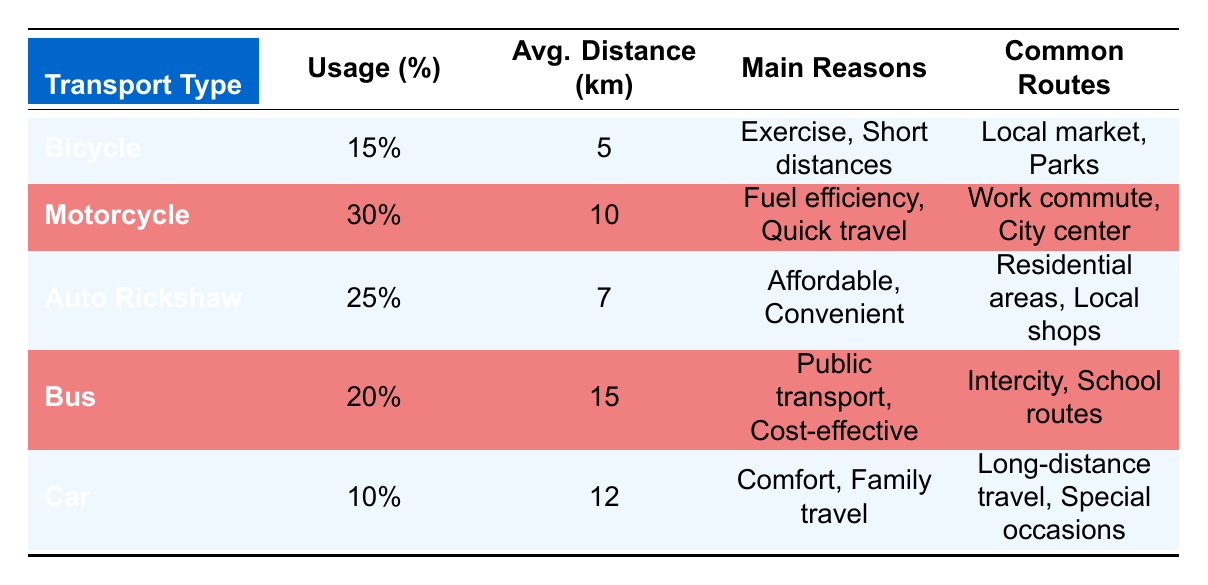What is the most commonly used mode of transportation in Jalalpore? According to the table, the mode of transportation with the highest usage percentage is the Motorcycle at 30%.
Answer: Motorcycle What percentage of residents use Bicycles for transportation? The table shows that 15% of residents use Bicycles.
Answer: 15% What is the average distance traveled by Bus users? The average distance traveled by Bus users is indicated in the table as 15 km.
Answer: 15 km Which transportation type is used for long-distance travel? The Car is highlighted in the table as the type used for long-distance travel, as it is mentioned in the common routes.
Answer: Car Are Auto Rickshaws more commonly used than Cars? Yes, Auto Rickshaws have a usage percentage of 25%, while Cars have only 10%, confirming that Auto Rickshaws are more commonly used.
Answer: Yes What is the average distance traveled by users of all transportation types combined? To find the average distance traveled, we should calculate the weighted average based on usage. Multiplying each average distance by its usage percentage and summing them up gives us (5*0.15 + 10*0.30 + 7*0.25 + 15*0.20 + 12*0.10) = 8.55 km. The average distance traveled by users of all transportation types is approximately 8.55 km.
Answer: 8.55 km Which type of transportation has the least common usage amongst the residents? The Car has the least common usage at 10%, as indicated in the table.
Answer: Car Is the primary reason for using a Motorcycle more focused on fuel efficiency than for using a Bus? Yes, the main reasons for Motorcycle usage include fuel efficiency, whereas Bus usage is mainly viewed as public transport and cost-effective, but does not focus on fuel efficiency.
Answer: Yes What is the percentage of residents using public transportation methods? Public transportation methods refer to the Bus and Auto Rickshaw. Adding their percentages, we find 20% (Bus) + 25% (Auto Rickshaw) = 45%. Therefore, the percentage of residents using public transportation methods is 45%.
Answer: 45% 